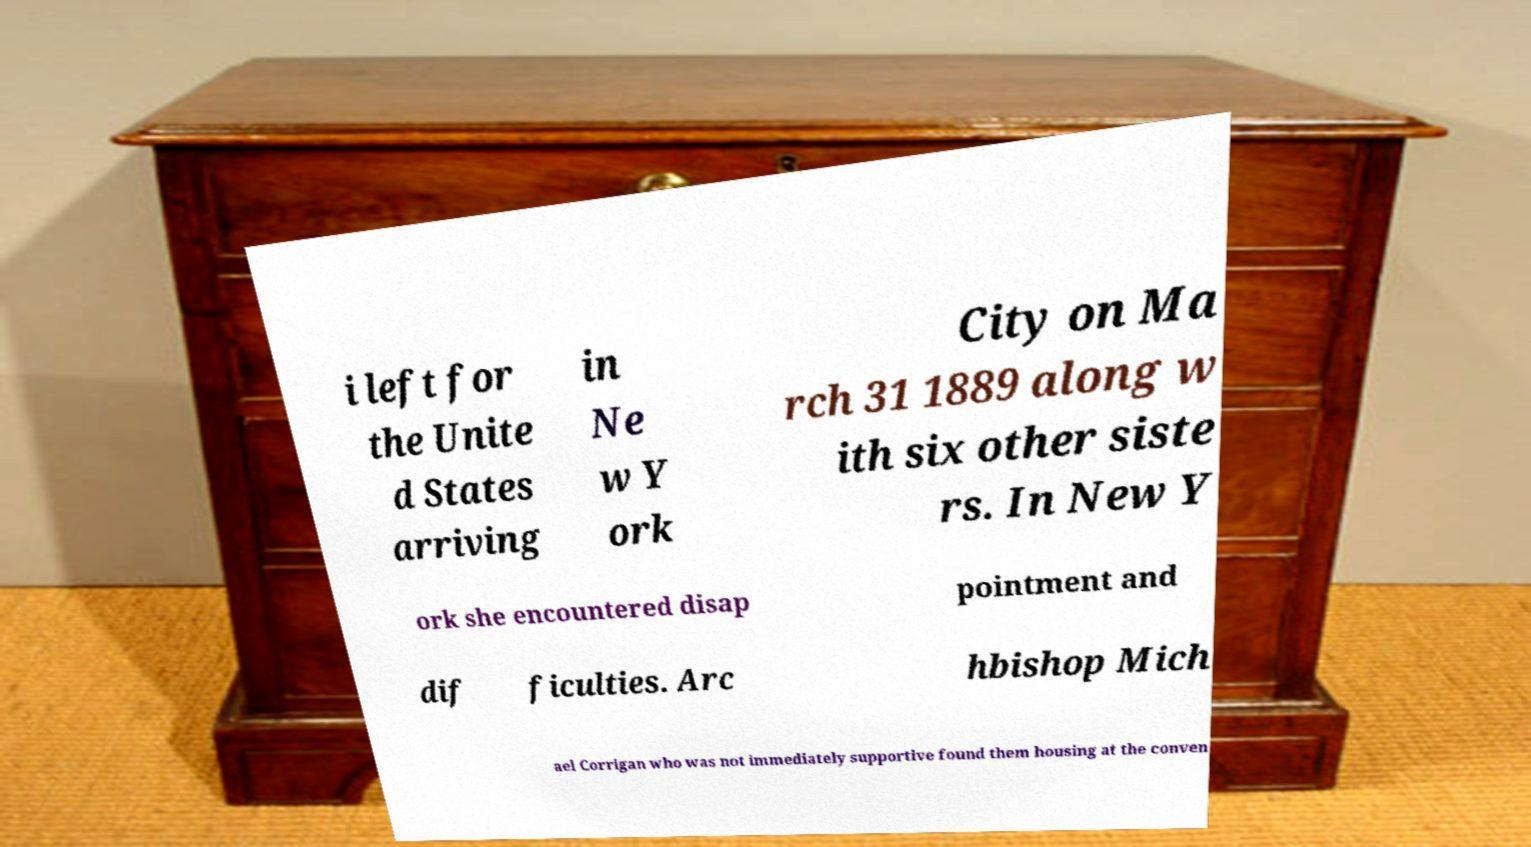Could you assist in decoding the text presented in this image and type it out clearly? i left for the Unite d States arriving in Ne w Y ork City on Ma rch 31 1889 along w ith six other siste rs. In New Y ork she encountered disap pointment and dif ficulties. Arc hbishop Mich ael Corrigan who was not immediately supportive found them housing at the conven 